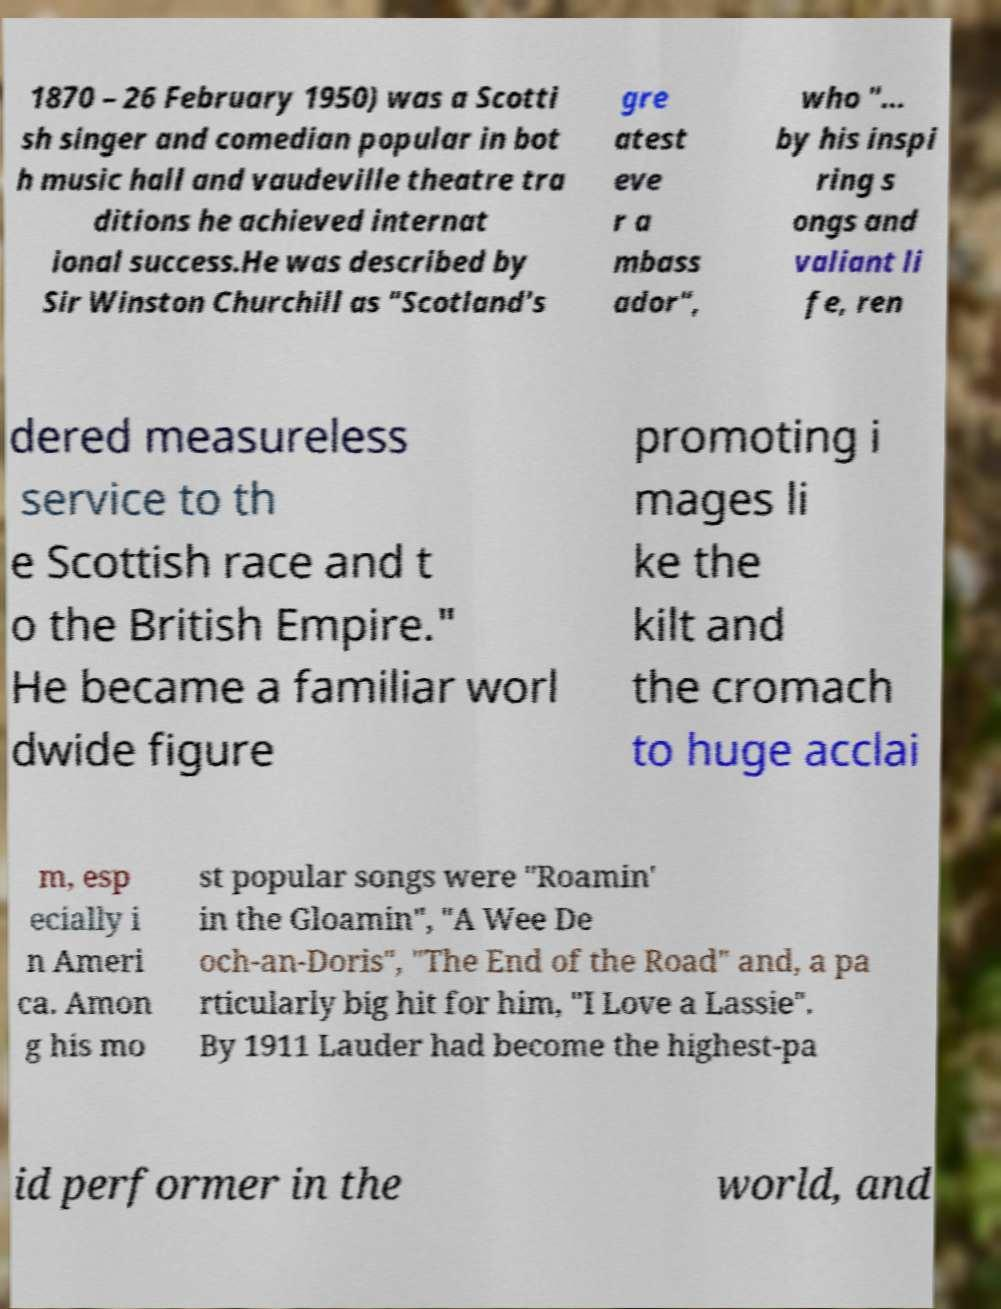I need the written content from this picture converted into text. Can you do that? 1870 – 26 February 1950) was a Scotti sh singer and comedian popular in bot h music hall and vaudeville theatre tra ditions he achieved internat ional success.He was described by Sir Winston Churchill as "Scotland's gre atest eve r a mbass ador", who "... by his inspi ring s ongs and valiant li fe, ren dered measureless service to th e Scottish race and t o the British Empire." He became a familiar worl dwide figure promoting i mages li ke the kilt and the cromach to huge acclai m, esp ecially i n Ameri ca. Amon g his mo st popular songs were "Roamin' in the Gloamin", "A Wee De och-an-Doris", "The End of the Road" and, a pa rticularly big hit for him, "I Love a Lassie". By 1911 Lauder had become the highest-pa id performer in the world, and 